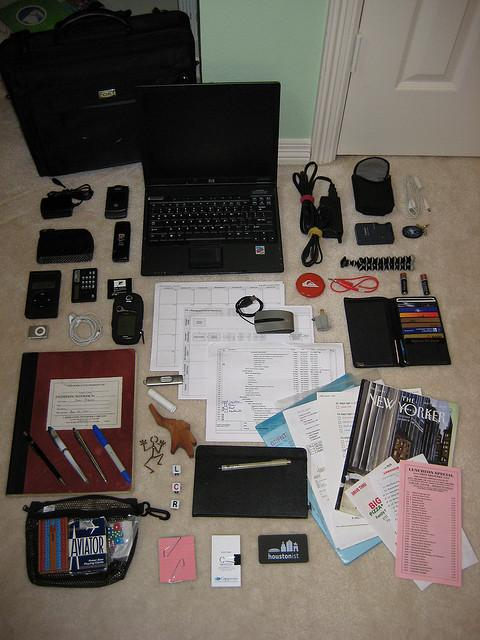How many laptops do you see?

Choices:
A) none
B) one
C) three
D) two one 